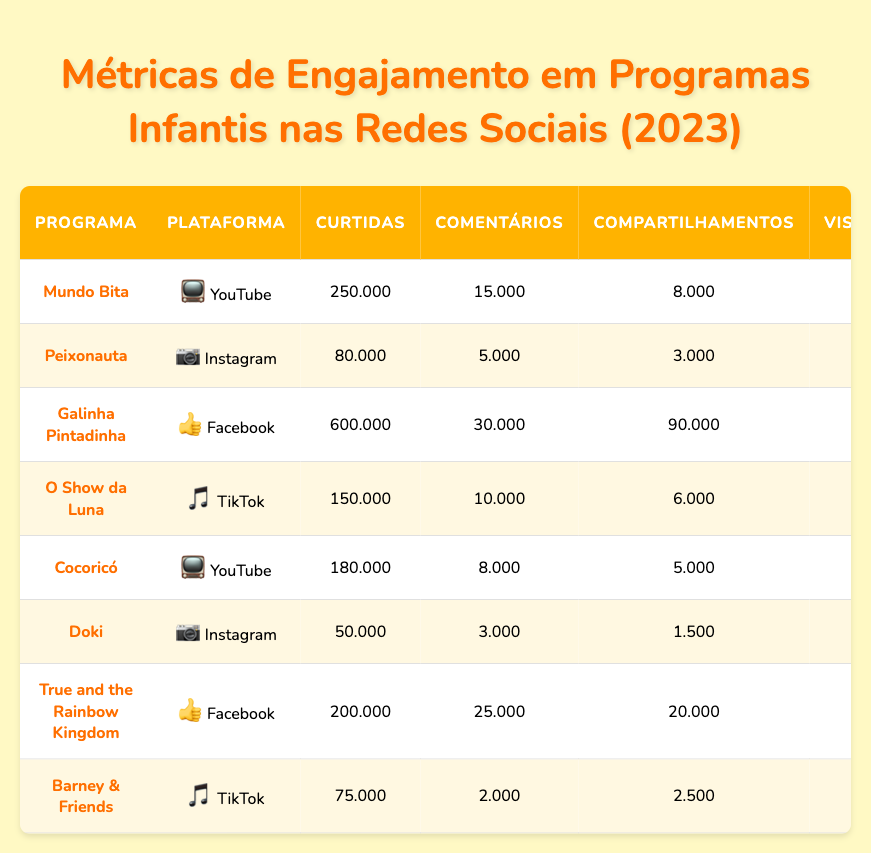What is the program with the highest number of likes on YouTube? Referring to the table, "Mundo Bita" has 250,000 likes, which is the highest count among YouTube programs listed.
Answer: Mundo Bita Which program has the most comments on Facebook? "Galinha Pintadinha" has the highest number of comments on Facebook with 30,000 comments according to the table.
Answer: Galinha Pintadinha How many shares does "O Show da Luna" have on TikTok? The table indicates that "O Show da Luna" has 6,000 shares on TikTok.
Answer: 6,000 What is the total number of likes for all programs on Instagram? "Peixonauta" has 80,000 likes and "Doki" has 50,000 likes; the sum is 80,000 + 50,000 = 130,000 likes.
Answer: 130,000 Does "True and the Rainbow Kingdom" have more likes than "Barney & Friends"? "True and the Rainbow Kingdom" has 200,000 likes, while "Barney & Friends" has 75,000 likes, confirming that it has more likes.
Answer: Yes What is the average engagement rate for the programs listed on Instagram? Calculate the average engagement rate from "Peixonauta" (0.05), and "Doki" (0.06): (0.05 + 0.06) / 2 = 0.055 or 5.5%.
Answer: 5.5% Which program on TikTok has the longest average watch time? "Barney & Friends" has an average watch time of 20 seconds, while "O Show da Luna" has 15 seconds, making "Barney & Friends" the longest.
Answer: Barney & Friends What percentage of "Galinha Pintadinha" comments are from likes? The number of likes is 600,000 and comments are 30,000. Calculate the percentage: (30,000 / 600,000) * 100 = 5%.
Answer: 5% How do the total views of YouTube programs compare to TikTok programs? "Mundo Bita" (50,000,000) and "Cocoricó" (20,000,000) on YouTube have a total of 70,000,000 views. TikTok programs "O Show da Luna" (30,000,000) and "Barney & Friends" (15,000,000) total 45,000,000 views, thus YouTube programs have more views.
Answer: YouTube programs have more views Which platform has the highest number of followers among the programs listed? "Galinha Pintadinha" has the highest number of followers with 2,500,000 on Facebook.
Answer: Facebook 